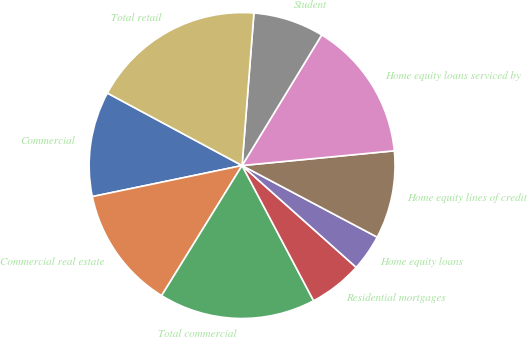Convert chart. <chart><loc_0><loc_0><loc_500><loc_500><pie_chart><fcel>Commercial<fcel>Commercial real estate<fcel>Total commercial<fcel>Residential mortgages<fcel>Home equity loans<fcel>Home equity lines of credit<fcel>Home equity loans serviced by<fcel>Student<fcel>Total retail<nl><fcel>11.11%<fcel>12.93%<fcel>16.56%<fcel>5.66%<fcel>3.84%<fcel>9.29%<fcel>14.75%<fcel>7.48%<fcel>18.38%<nl></chart> 